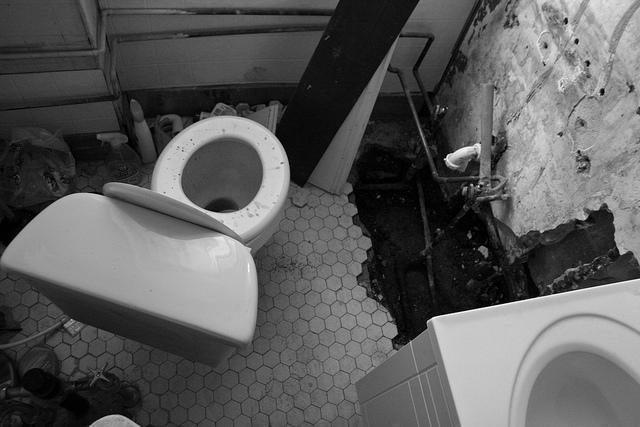What usually goes inside of the item with the lid?
From the following four choices, select the correct answer to address the question.
Options: Human waste, towels, cows, mcdonald's. Human waste. 